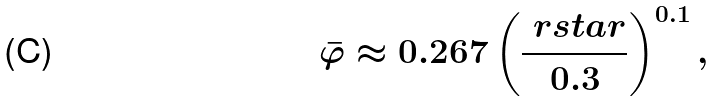<formula> <loc_0><loc_0><loc_500><loc_500>\bar { \varphi } \approx 0 . 2 6 7 \left ( \frac { \ r s t a r } { 0 . 3 } \right ) ^ { 0 . 1 } ,</formula> 